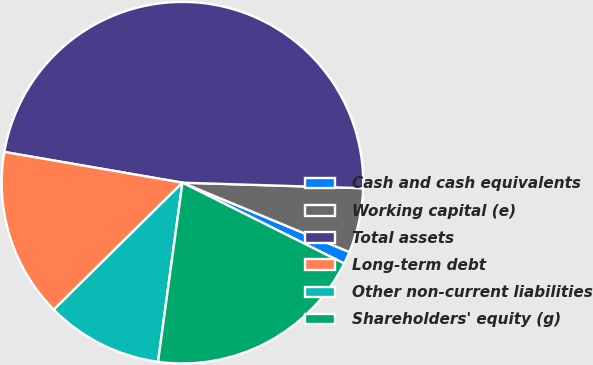Convert chart. <chart><loc_0><loc_0><loc_500><loc_500><pie_chart><fcel>Cash and cash equivalents<fcel>Working capital (e)<fcel>Total assets<fcel>Long-term debt<fcel>Other non-current liabilities<fcel>Shareholders' equity (g)<nl><fcel>1.11%<fcel>5.78%<fcel>47.77%<fcel>15.11%<fcel>10.45%<fcel>19.78%<nl></chart> 